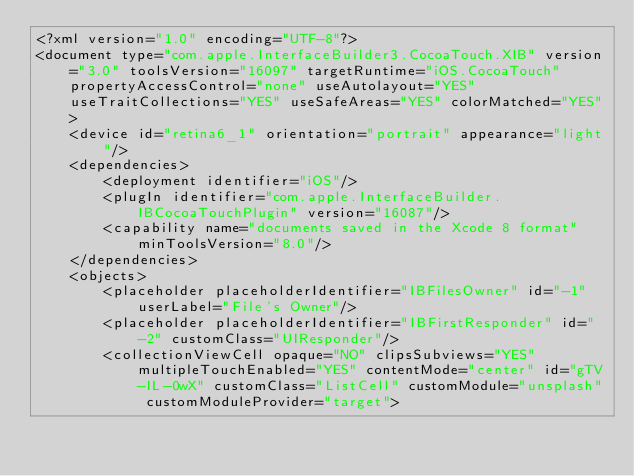<code> <loc_0><loc_0><loc_500><loc_500><_XML_><?xml version="1.0" encoding="UTF-8"?>
<document type="com.apple.InterfaceBuilder3.CocoaTouch.XIB" version="3.0" toolsVersion="16097" targetRuntime="iOS.CocoaTouch" propertyAccessControl="none" useAutolayout="YES" useTraitCollections="YES" useSafeAreas="YES" colorMatched="YES">
    <device id="retina6_1" orientation="portrait" appearance="light"/>
    <dependencies>
        <deployment identifier="iOS"/>
        <plugIn identifier="com.apple.InterfaceBuilder.IBCocoaTouchPlugin" version="16087"/>
        <capability name="documents saved in the Xcode 8 format" minToolsVersion="8.0"/>
    </dependencies>
    <objects>
        <placeholder placeholderIdentifier="IBFilesOwner" id="-1" userLabel="File's Owner"/>
        <placeholder placeholderIdentifier="IBFirstResponder" id="-2" customClass="UIResponder"/>
        <collectionViewCell opaque="NO" clipsSubviews="YES" multipleTouchEnabled="YES" contentMode="center" id="gTV-IL-0wX" customClass="ListCell" customModule="unsplash" customModuleProvider="target"></code> 